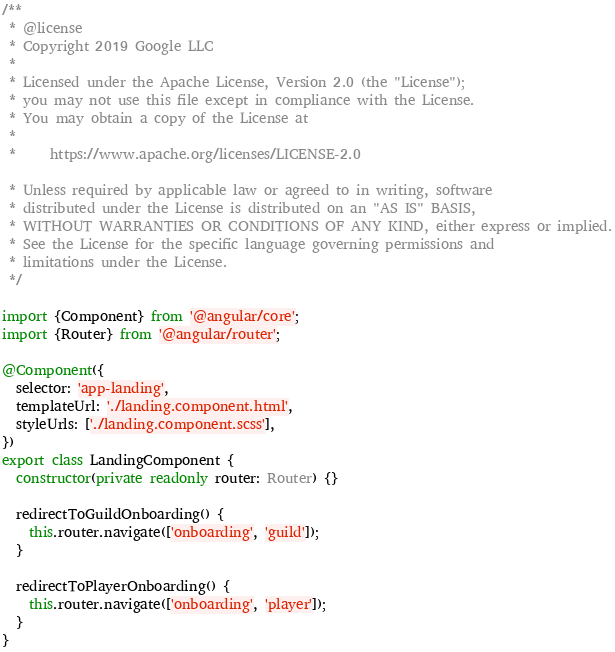Convert code to text. <code><loc_0><loc_0><loc_500><loc_500><_TypeScript_>/**
 * @license
 * Copyright 2019 Google LLC
 *
 * Licensed under the Apache License, Version 2.0 (the "License");
 * you may not use this file except in compliance with the License.
 * You may obtain a copy of the License at
 *
 *     https://www.apache.org/licenses/LICENSE-2.0

 * Unless required by applicable law or agreed to in writing, software
 * distributed under the License is distributed on an "AS IS" BASIS,
 * WITHOUT WARRANTIES OR CONDITIONS OF ANY KIND, either express or implied.
 * See the License for the specific language governing permissions and
 * limitations under the License.
 */

import {Component} from '@angular/core';
import {Router} from '@angular/router';

@Component({
  selector: 'app-landing',
  templateUrl: './landing.component.html',
  styleUrls: ['./landing.component.scss'],
})
export class LandingComponent {
  constructor(private readonly router: Router) {}

  redirectToGuildOnboarding() {
    this.router.navigate(['onboarding', 'guild']);
  }

  redirectToPlayerOnboarding() {
    this.router.navigate(['onboarding', 'player']);
  }
}
</code> 